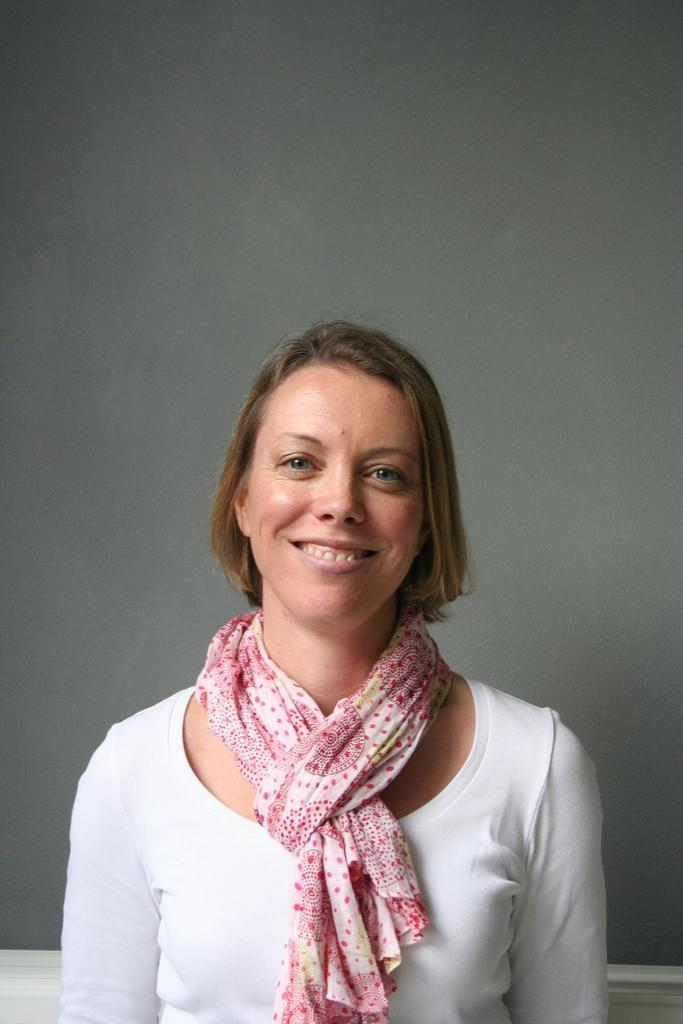Who is present in the image? There is a woman in the image. What is the woman wearing on her upper body? The woman is wearing a white shirt. What accessory is the woman wearing around her neck? The woman is wearing a red scarf. What color is the background of the image? The background of the image is gray. What type of wheel can be seen in the image? There is no wheel present in the image. What emotion is the woman expressing in the image? The image does not show any clear emotion, so it cannot be determined if the woman is expressing anger or any other emotion. 